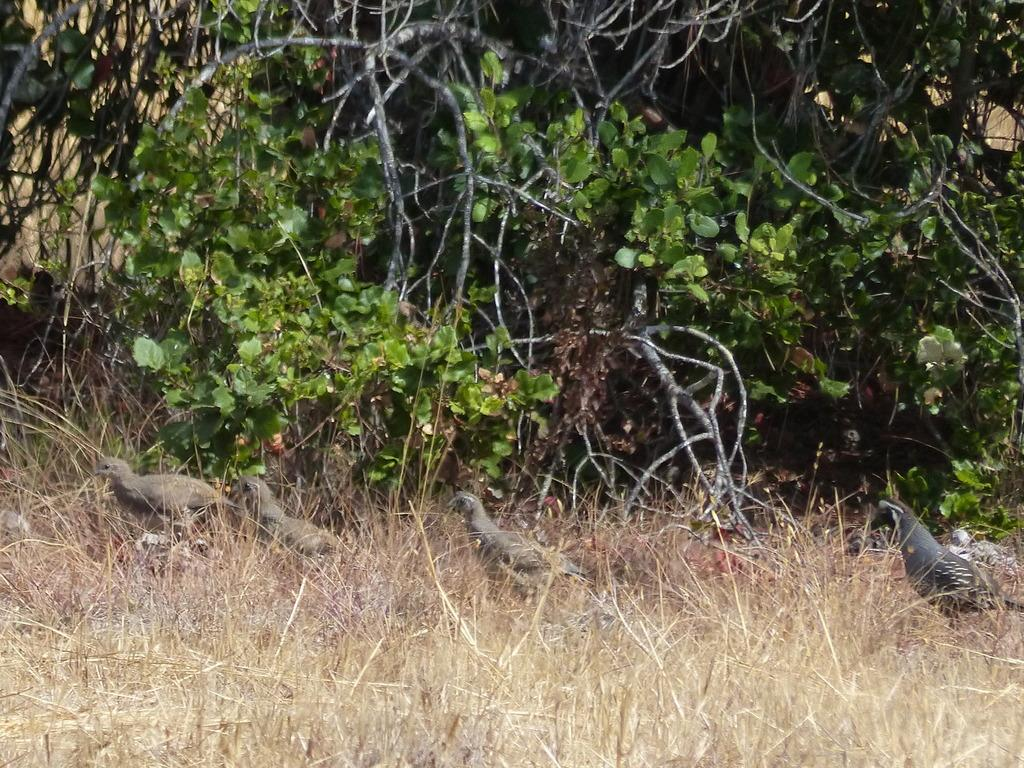What type of vegetation is present in the image? There is dried grass in the image. What animals can be seen on the dried grass? There are birds standing on the dried grass. What other types of vegetation are visible in the image? There are plants and bushes with twigs in the image. How many feet of dried grass are visible in the image? The amount of dried grass cannot be determined by its length in feet, as the image only shows a portion of the grass. 